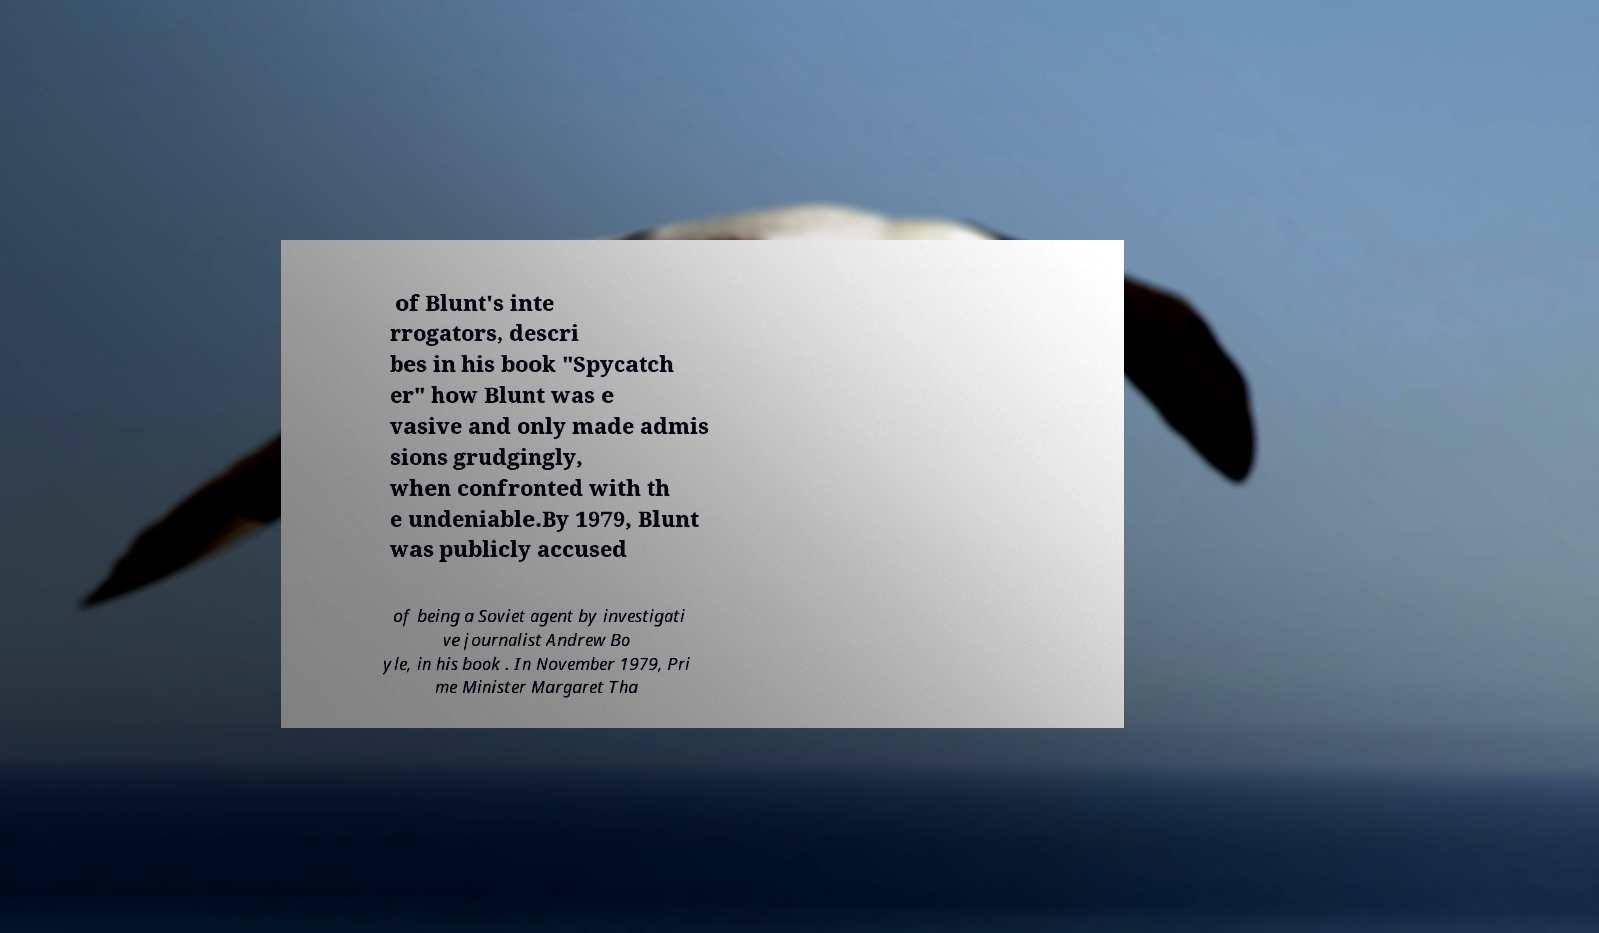I need the written content from this picture converted into text. Can you do that? of Blunt's inte rrogators, descri bes in his book "Spycatch er" how Blunt was e vasive and only made admis sions grudgingly, when confronted with th e undeniable.By 1979, Blunt was publicly accused of being a Soviet agent by investigati ve journalist Andrew Bo yle, in his book . In November 1979, Pri me Minister Margaret Tha 